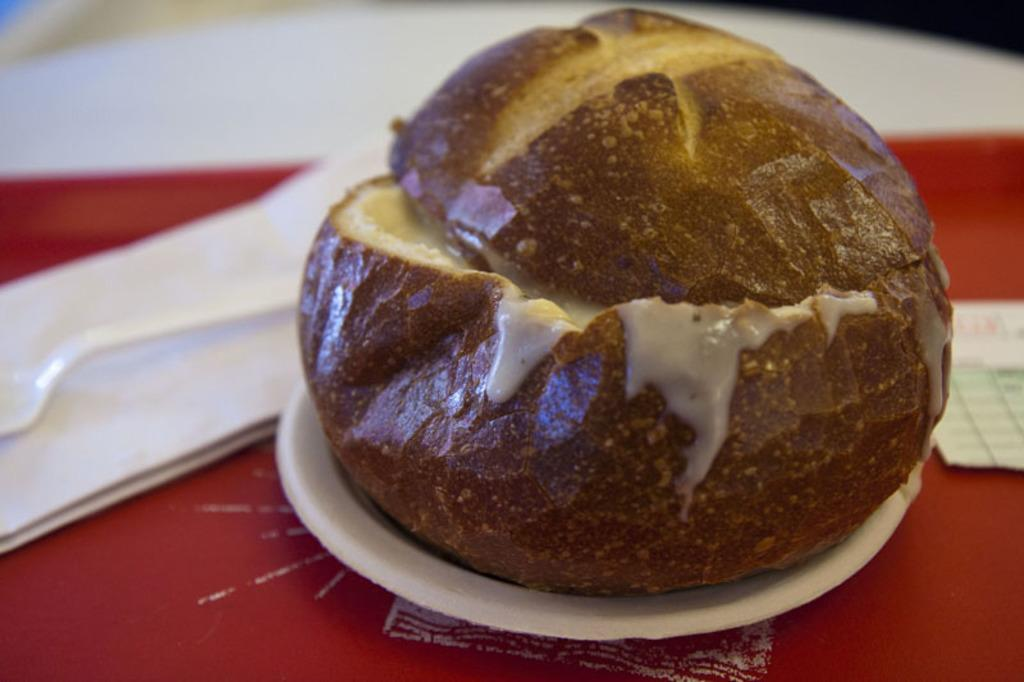What is on the plate in the image? There is a food item on a plate in the image. What color is the plate? The plate is white. Where is the spoon located in the image? The spoon is on the left side of the image. What color is the spoon? The spoon is white. What caption is written on the picture in the image? There is no picture or caption present in the image; it only contains a food item on a plate and a white spoon. 